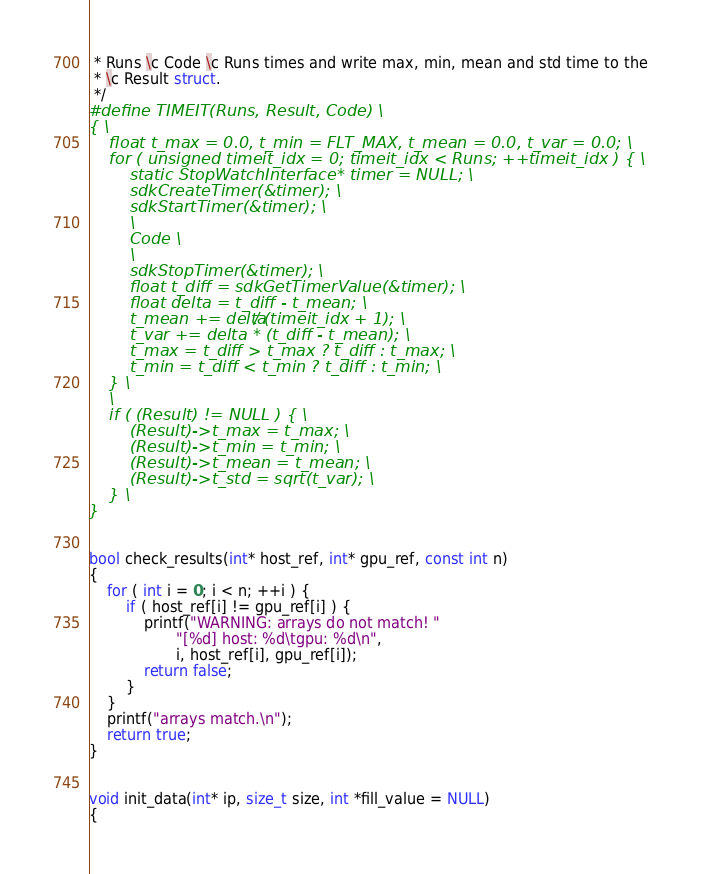<code> <loc_0><loc_0><loc_500><loc_500><_Cuda_> * Runs \c Code \c Runs times and write max, min, mean and std time to the
 * \c Result struct.
 */
#define TIMEIT(Runs, Result, Code) \
{ \
    float t_max = 0.0, t_min = FLT_MAX, t_mean = 0.0, t_var = 0.0; \
    for ( unsigned timeit_idx = 0; timeit_idx < Runs; ++timeit_idx ) { \
        static StopWatchInterface* timer = NULL; \
        sdkCreateTimer(&timer); \
        sdkStartTimer(&timer); \
        \
        Code \
        \
        sdkStopTimer(&timer); \
      	float t_diff = sdkGetTimerValue(&timer); \
        float delta = t_diff - t_mean; \
        t_mean += delta / (timeit_idx + 1); \
        t_var += delta * (t_diff - t_mean); \
        t_max = t_diff > t_max ? t_diff : t_max; \
        t_min = t_diff < t_min ? t_diff : t_min; \
    } \
    \
    if ( (Result) != NULL ) { \
        (Result)->t_max = t_max; \
        (Result)->t_min = t_min; \
        (Result)->t_mean = t_mean; \
        (Result)->t_std = sqrt(t_var); \
    } \
}


bool check_results(int* host_ref, int* gpu_ref, const int n)
{
    for ( int i = 0; i < n; ++i ) {
        if ( host_ref[i] != gpu_ref[i] ) {
            printf("WARNING: arrays do not match! "
                   "[%d] host: %d\tgpu: %d\n",
                   i, host_ref[i], gpu_ref[i]);
            return false;
        }
    }
    printf("arrays match.\n");
    return true;
}


void init_data(int* ip, size_t size, int *fill_value = NULL)
{</code> 